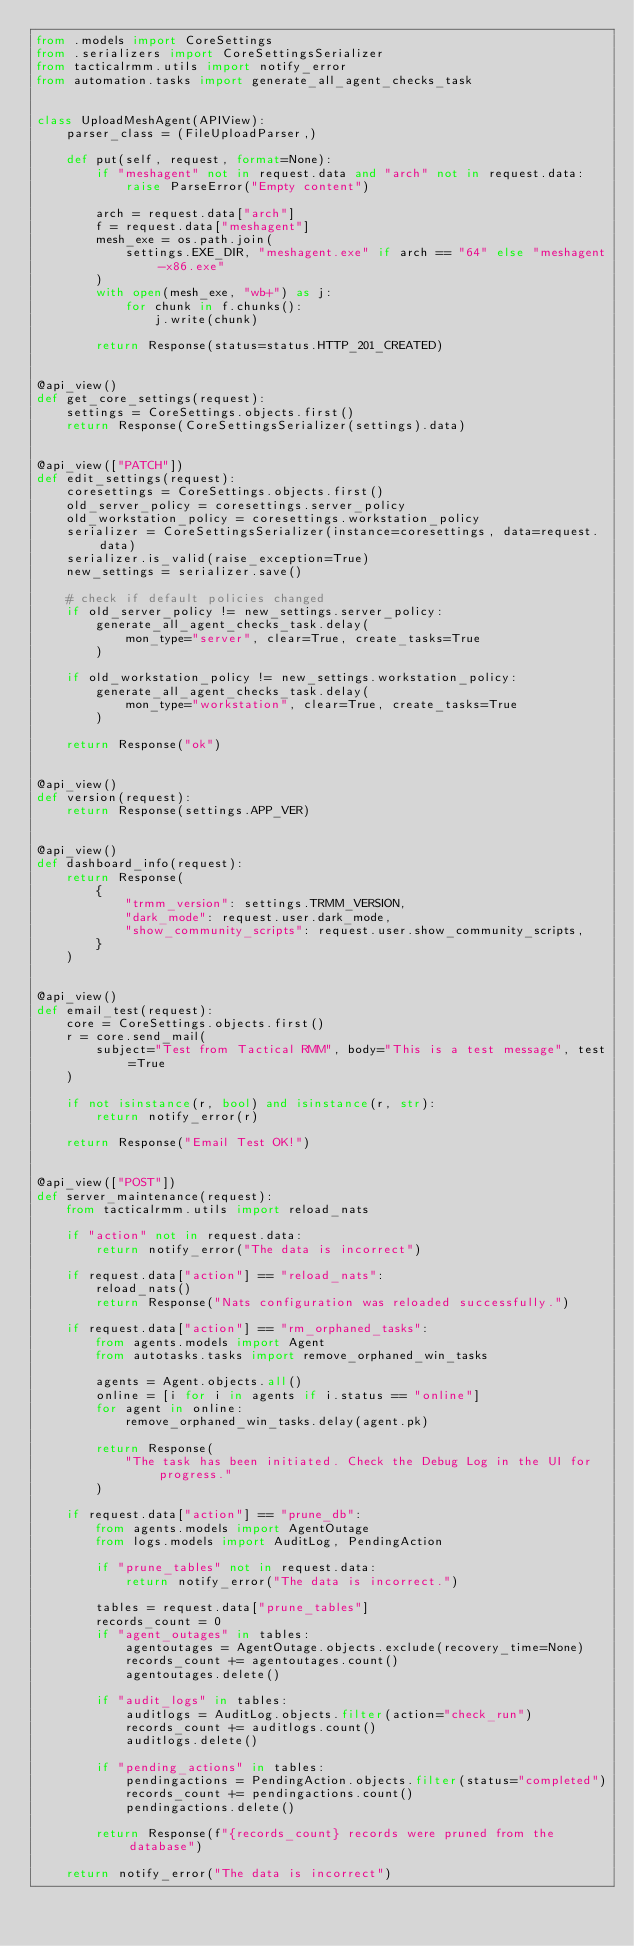Convert code to text. <code><loc_0><loc_0><loc_500><loc_500><_Python_>from .models import CoreSettings
from .serializers import CoreSettingsSerializer
from tacticalrmm.utils import notify_error
from automation.tasks import generate_all_agent_checks_task


class UploadMeshAgent(APIView):
    parser_class = (FileUploadParser,)

    def put(self, request, format=None):
        if "meshagent" not in request.data and "arch" not in request.data:
            raise ParseError("Empty content")

        arch = request.data["arch"]
        f = request.data["meshagent"]
        mesh_exe = os.path.join(
            settings.EXE_DIR, "meshagent.exe" if arch == "64" else "meshagent-x86.exe"
        )
        with open(mesh_exe, "wb+") as j:
            for chunk in f.chunks():
                j.write(chunk)

        return Response(status=status.HTTP_201_CREATED)


@api_view()
def get_core_settings(request):
    settings = CoreSettings.objects.first()
    return Response(CoreSettingsSerializer(settings).data)


@api_view(["PATCH"])
def edit_settings(request):
    coresettings = CoreSettings.objects.first()
    old_server_policy = coresettings.server_policy
    old_workstation_policy = coresettings.workstation_policy
    serializer = CoreSettingsSerializer(instance=coresettings, data=request.data)
    serializer.is_valid(raise_exception=True)
    new_settings = serializer.save()

    # check if default policies changed
    if old_server_policy != new_settings.server_policy:
        generate_all_agent_checks_task.delay(
            mon_type="server", clear=True, create_tasks=True
        )

    if old_workstation_policy != new_settings.workstation_policy:
        generate_all_agent_checks_task.delay(
            mon_type="workstation", clear=True, create_tasks=True
        )

    return Response("ok")


@api_view()
def version(request):
    return Response(settings.APP_VER)


@api_view()
def dashboard_info(request):
    return Response(
        {
            "trmm_version": settings.TRMM_VERSION,
            "dark_mode": request.user.dark_mode,
            "show_community_scripts": request.user.show_community_scripts,
        }
    )


@api_view()
def email_test(request):
    core = CoreSettings.objects.first()
    r = core.send_mail(
        subject="Test from Tactical RMM", body="This is a test message", test=True
    )

    if not isinstance(r, bool) and isinstance(r, str):
        return notify_error(r)

    return Response("Email Test OK!")


@api_view(["POST"])
def server_maintenance(request):
    from tacticalrmm.utils import reload_nats

    if "action" not in request.data:
        return notify_error("The data is incorrect")

    if request.data["action"] == "reload_nats":
        reload_nats()
        return Response("Nats configuration was reloaded successfully.")

    if request.data["action"] == "rm_orphaned_tasks":
        from agents.models import Agent
        from autotasks.tasks import remove_orphaned_win_tasks

        agents = Agent.objects.all()
        online = [i for i in agents if i.status == "online"]
        for agent in online:
            remove_orphaned_win_tasks.delay(agent.pk)

        return Response(
            "The task has been initiated. Check the Debug Log in the UI for progress."
        )

    if request.data["action"] == "prune_db":
        from agents.models import AgentOutage
        from logs.models import AuditLog, PendingAction

        if "prune_tables" not in request.data:
            return notify_error("The data is incorrect.")

        tables = request.data["prune_tables"]
        records_count = 0
        if "agent_outages" in tables:
            agentoutages = AgentOutage.objects.exclude(recovery_time=None)
            records_count += agentoutages.count()
            agentoutages.delete()

        if "audit_logs" in tables:
            auditlogs = AuditLog.objects.filter(action="check_run")
            records_count += auditlogs.count()
            auditlogs.delete()

        if "pending_actions" in tables:
            pendingactions = PendingAction.objects.filter(status="completed")
            records_count += pendingactions.count()
            pendingactions.delete()

        return Response(f"{records_count} records were pruned from the database")

    return notify_error("The data is incorrect")
</code> 